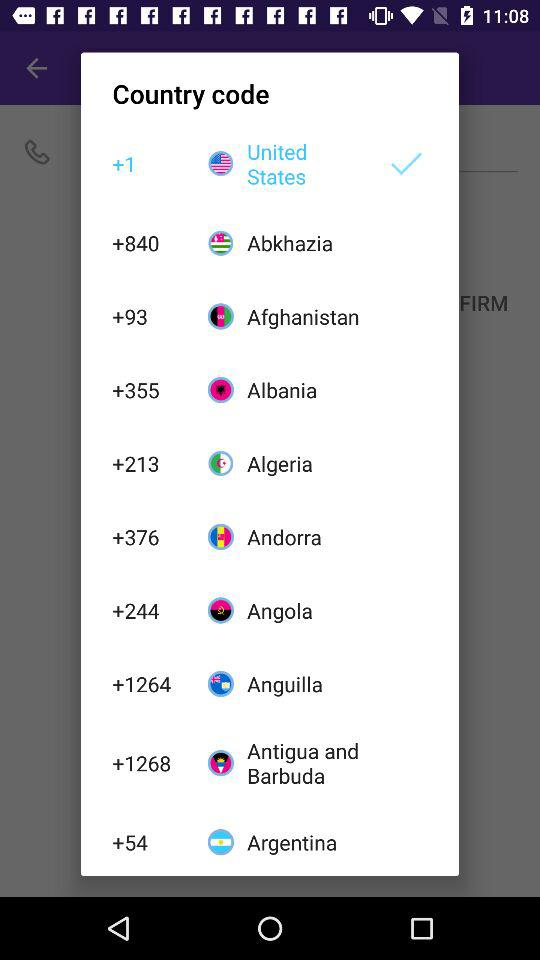Which country code is +93? The country code +93 is for Afghanistan. 